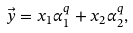Convert formula to latex. <formula><loc_0><loc_0><loc_500><loc_500>\vec { y } = x _ { 1 } \alpha _ { 1 } ^ { q } + x _ { 2 } \alpha _ { 2 } ^ { q } ,</formula> 